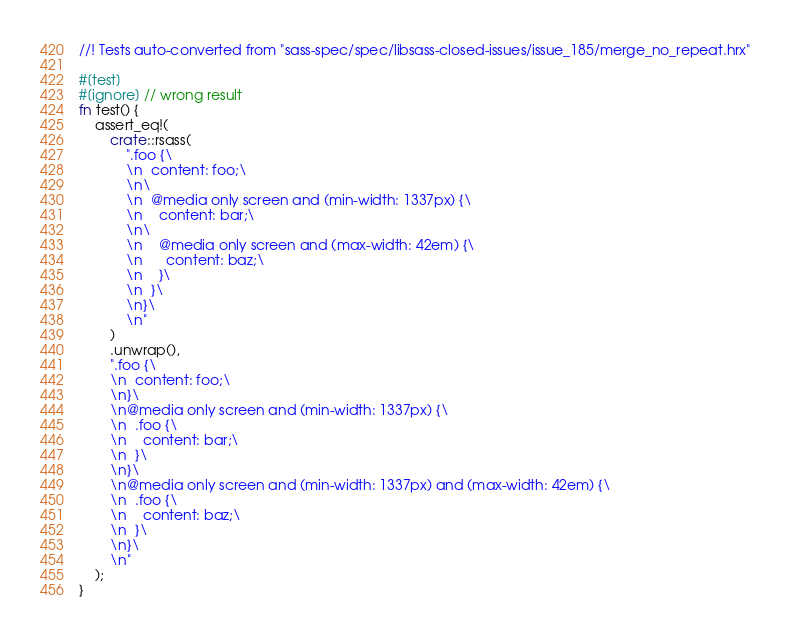<code> <loc_0><loc_0><loc_500><loc_500><_Rust_>//! Tests auto-converted from "sass-spec/spec/libsass-closed-issues/issue_185/merge_no_repeat.hrx"

#[test]
#[ignore] // wrong result
fn test() {
    assert_eq!(
        crate::rsass(
            ".foo {\
            \n  content: foo;\
            \n\
            \n  @media only screen and (min-width: 1337px) {\
            \n    content: bar;\
            \n\
            \n    @media only screen and (max-width: 42em) {\
            \n      content: baz;\
            \n    }\
            \n  }\
            \n}\
            \n"
        )
        .unwrap(),
        ".foo {\
        \n  content: foo;\
        \n}\
        \n@media only screen and (min-width: 1337px) {\
        \n  .foo {\
        \n    content: bar;\
        \n  }\
        \n}\
        \n@media only screen and (min-width: 1337px) and (max-width: 42em) {\
        \n  .foo {\
        \n    content: baz;\
        \n  }\
        \n}\
        \n"
    );
}
</code> 